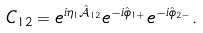Convert formula to latex. <formula><loc_0><loc_0><loc_500><loc_500>C _ { 1 2 } = e ^ { i \eta _ { 1 } \hat { \mathcal { A } } _ { 1 2 } } e ^ { - i \hat { \phi } _ { 1 + } } e ^ { - i \hat { \phi } _ { 2 - } } .</formula> 